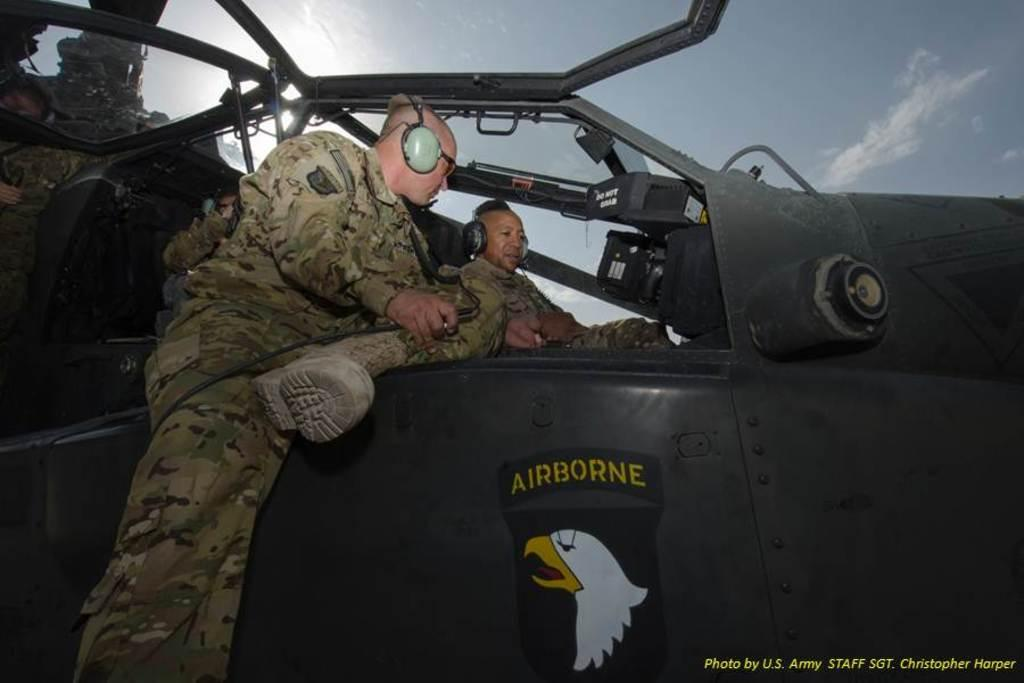<image>
Summarize the visual content of the image. Two pilots talking in the cockpit of a helicopter with "Airborne" written on the side. 